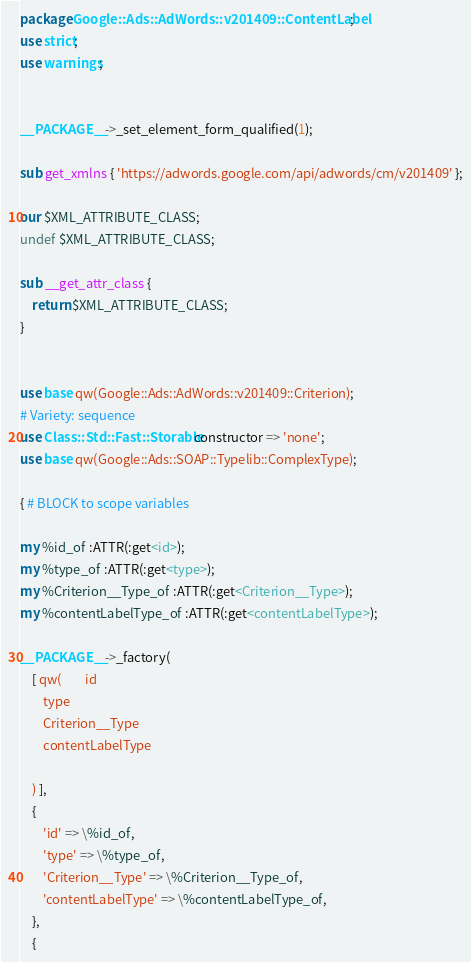Convert code to text. <code><loc_0><loc_0><loc_500><loc_500><_Perl_>package Google::Ads::AdWords::v201409::ContentLabel;
use strict;
use warnings;


__PACKAGE__->_set_element_form_qualified(1);

sub get_xmlns { 'https://adwords.google.com/api/adwords/cm/v201409' };

our $XML_ATTRIBUTE_CLASS;
undef $XML_ATTRIBUTE_CLASS;

sub __get_attr_class {
    return $XML_ATTRIBUTE_CLASS;
}


use base qw(Google::Ads::AdWords::v201409::Criterion);
# Variety: sequence
use Class::Std::Fast::Storable constructor => 'none';
use base qw(Google::Ads::SOAP::Typelib::ComplexType);

{ # BLOCK to scope variables

my %id_of :ATTR(:get<id>);
my %type_of :ATTR(:get<type>);
my %Criterion__Type_of :ATTR(:get<Criterion__Type>);
my %contentLabelType_of :ATTR(:get<contentLabelType>);

__PACKAGE__->_factory(
    [ qw(        id
        type
        Criterion__Type
        contentLabelType

    ) ],
    {
        'id' => \%id_of,
        'type' => \%type_of,
        'Criterion__Type' => \%Criterion__Type_of,
        'contentLabelType' => \%contentLabelType_of,
    },
    {</code> 